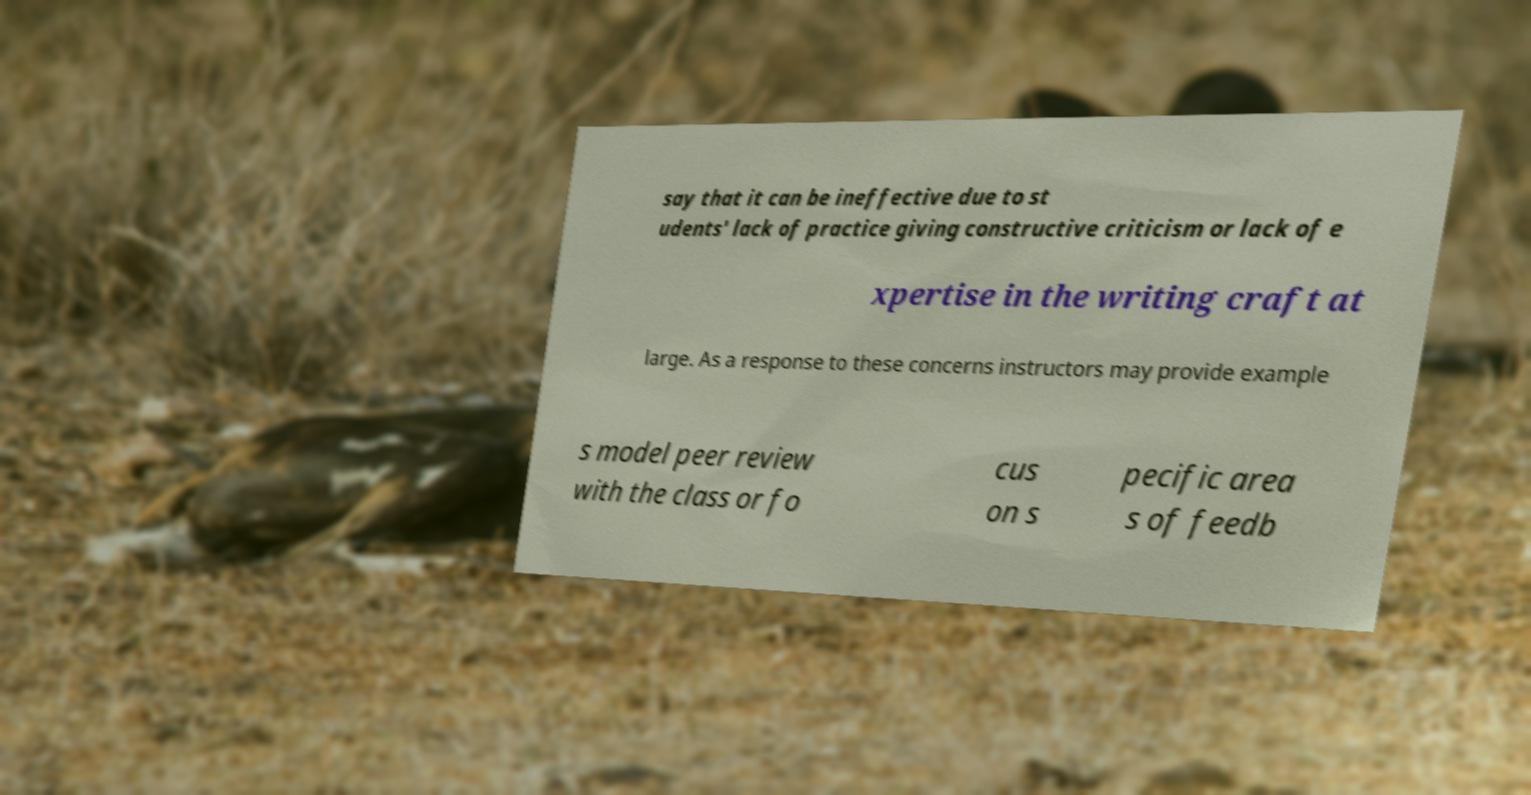Could you extract and type out the text from this image? say that it can be ineffective due to st udents' lack of practice giving constructive criticism or lack of e xpertise in the writing craft at large. As a response to these concerns instructors may provide example s model peer review with the class or fo cus on s pecific area s of feedb 